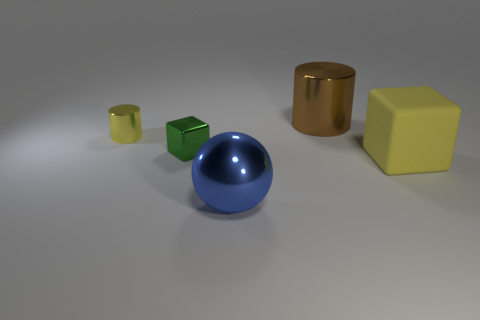What is the material of the big thing that is to the left of the large rubber thing and behind the metallic ball?
Your answer should be very brief. Metal. Is there a big block that is in front of the cube to the right of the big blue shiny sphere?
Give a very brief answer. No. What number of large spheres are the same color as the big cylinder?
Provide a short and direct response. 0. What is the material of the cube that is the same color as the small metallic cylinder?
Keep it short and to the point. Rubber. Do the tiny green cube and the brown cylinder have the same material?
Offer a terse response. Yes. Are there any large brown cylinders to the left of the yellow cylinder?
Keep it short and to the point. No. There is a cylinder to the left of the large brown object on the right side of the ball; what is it made of?
Keep it short and to the point. Metal. There is another thing that is the same shape as the green shiny thing; what is its size?
Your answer should be very brief. Large. Does the small shiny cylinder have the same color as the matte block?
Your answer should be very brief. Yes. The object that is behind the large yellow matte block and right of the green metal object is what color?
Offer a very short reply. Brown. 